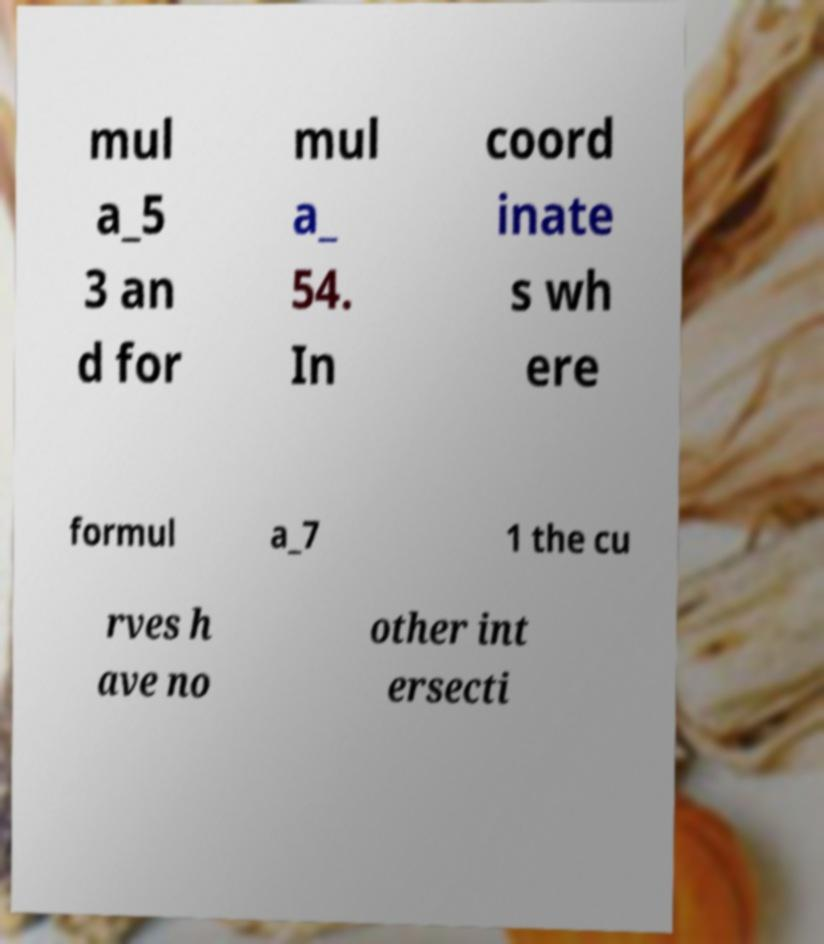Please read and relay the text visible in this image. What does it say? mul a_5 3 an d for mul a_ 54. In coord inate s wh ere formul a_7 1 the cu rves h ave no other int ersecti 